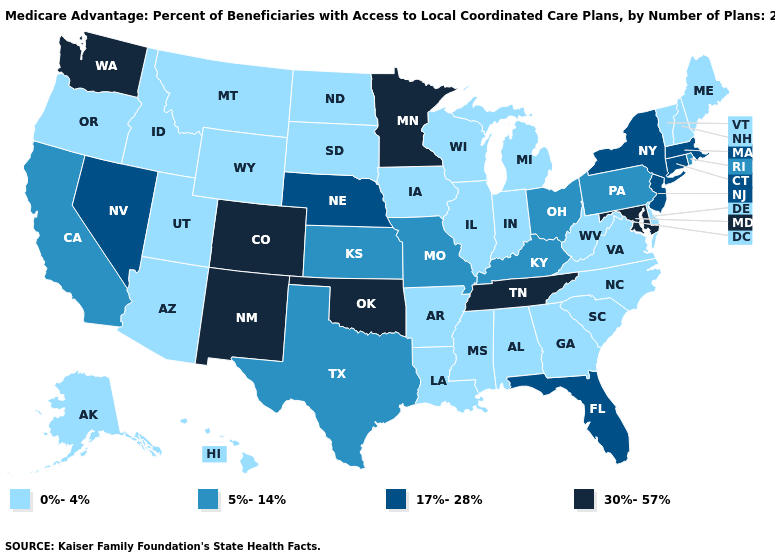Which states hav the highest value in the South?
Quick response, please. Maryland, Oklahoma, Tennessee. Which states hav the highest value in the South?
Concise answer only. Maryland, Oklahoma, Tennessee. Name the states that have a value in the range 0%-4%?
Quick response, please. Alaska, Alabama, Arkansas, Arizona, Delaware, Georgia, Hawaii, Iowa, Idaho, Illinois, Indiana, Louisiana, Maine, Michigan, Mississippi, Montana, North Carolina, North Dakota, New Hampshire, Oregon, South Carolina, South Dakota, Utah, Virginia, Vermont, Wisconsin, West Virginia, Wyoming. Does New York have the same value as Florida?
Give a very brief answer. Yes. What is the value of Ohio?
Answer briefly. 5%-14%. Does New Mexico have the lowest value in the USA?
Write a very short answer. No. Does the first symbol in the legend represent the smallest category?
Give a very brief answer. Yes. Does Delaware have the lowest value in the USA?
Write a very short answer. Yes. Does the first symbol in the legend represent the smallest category?
Answer briefly. Yes. Does Nevada have the lowest value in the USA?
Answer briefly. No. Among the states that border Ohio , does Kentucky have the lowest value?
Keep it brief. No. Among the states that border North Dakota , does South Dakota have the lowest value?
Keep it brief. Yes. What is the value of Montana?
Short answer required. 0%-4%. 